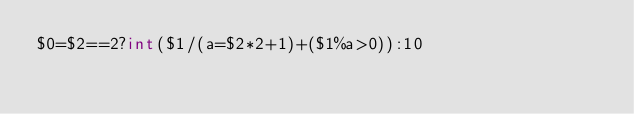<code> <loc_0><loc_0><loc_500><loc_500><_Awk_>$0=$2==2?int($1/(a=$2*2+1)+($1%a>0)):10</code> 